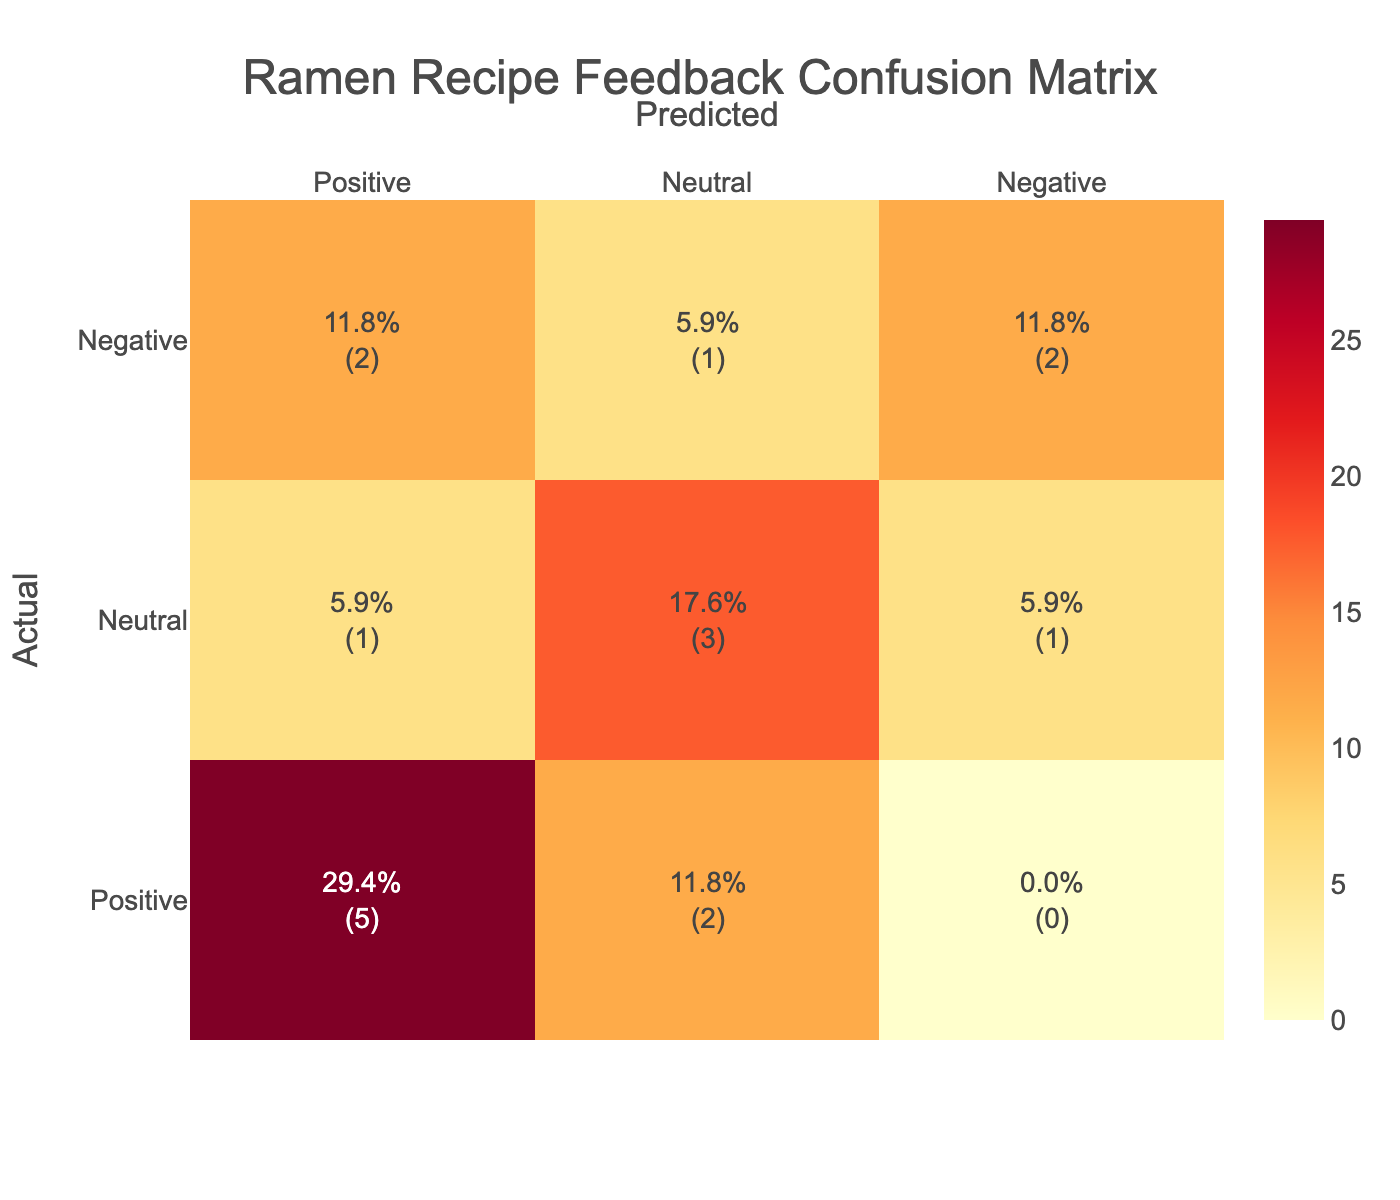What is the total number of positive feedbacks predicted? The confusion matrix shows that there are 5 instances where the feedback was predicted as Positive (2 True Positives and 3 False Positives from Neutral and Negative). Therefore, the total number is 5.
Answer: 5 How many actual Neutral feedbacks were predicted as Negative? The confusion matrix indicates that there were 1 instances of Neutral feedback that was incorrectly predicted as Negative.
Answer: 1 What is the percentage of correctly predicted Positive feedback? To find this, we need to divide the number of True Positives (which is 5) by the total number of Positive feedbacks (which is 8) and then multiply by 100. (5/8) * 100 = 62.5%.
Answer: 62.5% Is there any case where Negative feedback was predicted as Positive? Yes, there are 3 cases where actual Negative feedback was mistakenly predicted as Positive, as indicated in the table.
Answer: Yes How many feedback instances were correctly classified as Neutral? The table shows 4 instances where Neutral feedback was predicted correctly. This includes True Negatives (2) and instances where Positive was falsely classified as Neutral (2). Adding these gives a total of 4 for Neutral.
Answer: 4 What is the ratio of False Positives to True Positives? False Positives are instances where Negative and Neutral were predicted as Positive, leading to a total of 3 (1 Neutral, 2 Negative). True Positives are 5. Thus, the ratio is 3:5.
Answer: 3:5 What is the total amount of feedback given? To find the total feedback, we sum all the values in the confusion matrix. Adding gives us a total of 16 feedback instances across all categories.
Answer: 16 How many total feedbacks were classified as Negative? The confusion matrix indicates there are 6 Negative feedbacks predicted (2 True Negatives and 4 False Positives from Positive).
Answer: 6 What is the average percentage of correct predictions overall? To find this, first calculate the total correct predictions: 5 True Positives + 2 True Negatives + 4 True Neutrals = 11 correct outputs. Then dividing by total instances (16) gives us (11/16) * 100 = 68.75%.
Answer: 68.75% 